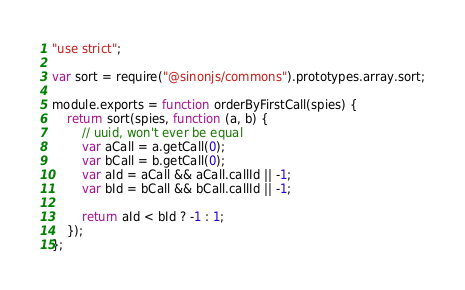<code> <loc_0><loc_0><loc_500><loc_500><_JavaScript_>"use strict";

var sort = require("@sinonjs/commons").prototypes.array.sort;

module.exports = function orderByFirstCall(spies) {
    return sort(spies, function (a, b) {
        // uuid, won't ever be equal
        var aCall = a.getCall(0);
        var bCall = b.getCall(0);
        var aId = aCall && aCall.callId || -1;
        var bId = bCall && bCall.callId || -1;

        return aId < bId ? -1 : 1;
    });
};
</code> 